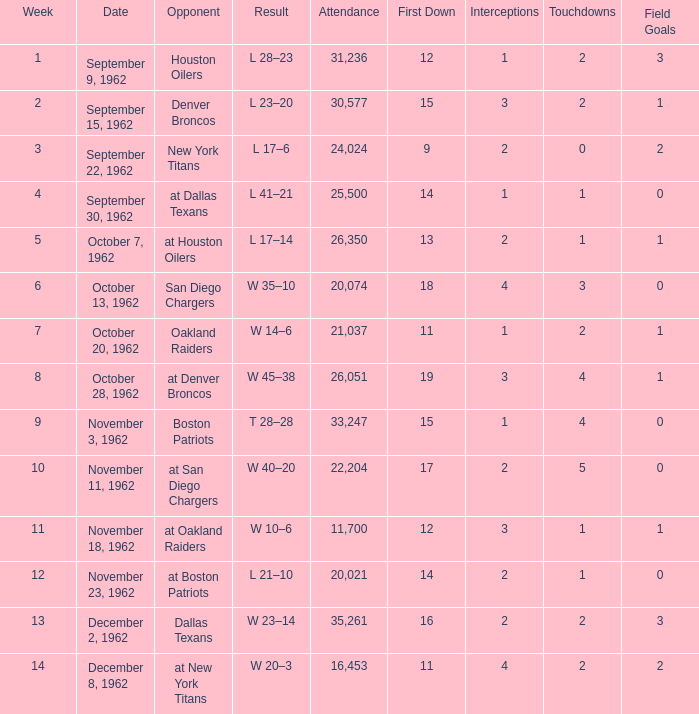What week was the attendance smaller than 22,204 on December 8, 1962? 14.0. 